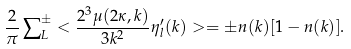Convert formula to latex. <formula><loc_0><loc_0><loc_500><loc_500>\frac { 2 } { \pi } \sum \nolimits _ { L } ^ { \pm } < \frac { 2 ^ { 3 } \mu ( 2 \kappa , k ) } { 3 k ^ { 2 } } \eta ^ { \prime } _ { l } ( k ) > = \pm n ( k ) [ 1 - n ( k ) ] .</formula> 